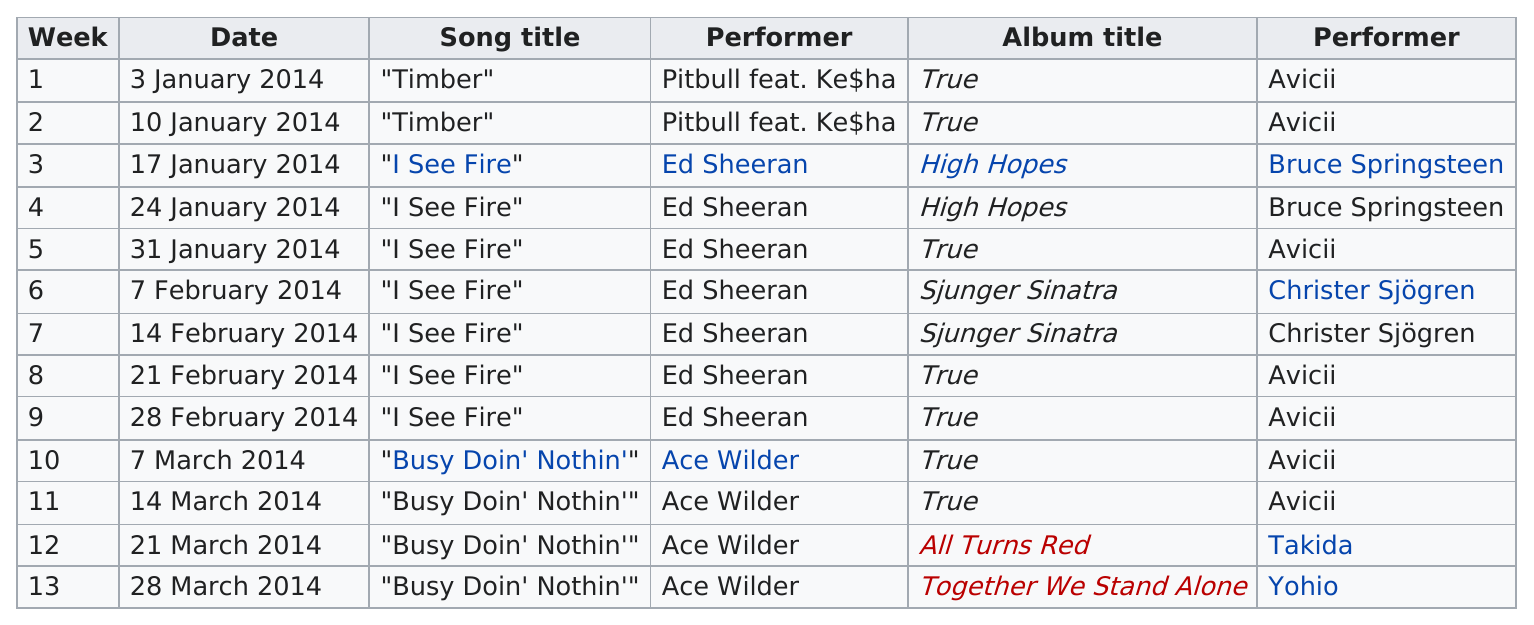Give some essential details in this illustration. For how many weeks was Timber on the list? 2.. The total number of songs released in January was 5. The first number one song of 2014 was 'Timber.' The last album title on this chart is "Together We Stand Alone...". The name of the first song title on this chart is 'Timber.' 